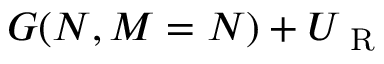<formula> <loc_0><loc_0><loc_500><loc_500>G ( N , M = N ) + U _ { R }</formula> 